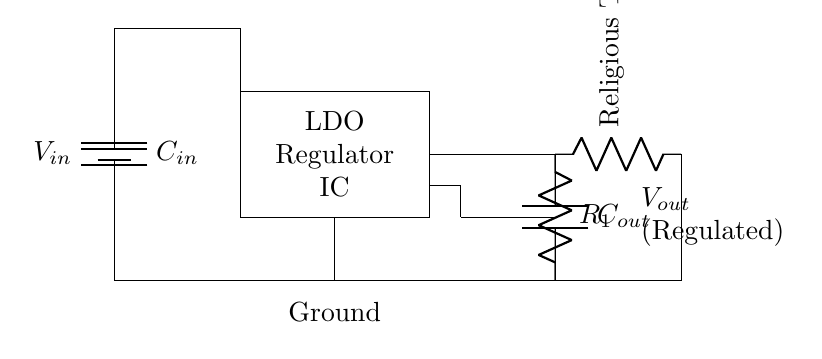What is the input voltage of this circuit? The input voltage is indicated by the label on the battery symbol, which represents the source of power for the circuit.
Answer: V in What is the purpose of the capacitors in this circuit? The capacitors, C in and C out, stabilize voltage and filter noise. C in smooths the input voltage while C out smooths the output voltage to ensure efficient operation.
Answer: Stabilization and filtering What is the function of the resistor labeled R1? The resistor R1 is part of the feedback mechanism that determines the output voltage level of the regulator. It helps maintain a stable output by providing a feedback signal.
Answer: Feedback control How does this regulator provide a regulated output voltage? The low-dropout regulator IC adjusts the output voltage based on the difference between the input voltage and the feedback from the output, ensuring that V out remains stable regardless of variations in load or input.
Answer: Regulation of output What is the load connected to the output of this regulator? The load is specified in the diagram as a religious text reader, which represents the device powered by the regulated voltage.
Answer: Religious text reader Which component is used for noise filtering at the input? The input capacitor, C in, is the component used to filter out any noise present in the input voltage to ensure clean power to the regulator.
Answer: C in How does the LDO help in battery life extension for the reader? The low-dropout nature of the regulator means it can operate efficiently with minimal voltage difference between input and output, which helps conserve battery life in portable applications like the religious text reader.
Answer: Efficiency in battery usage 